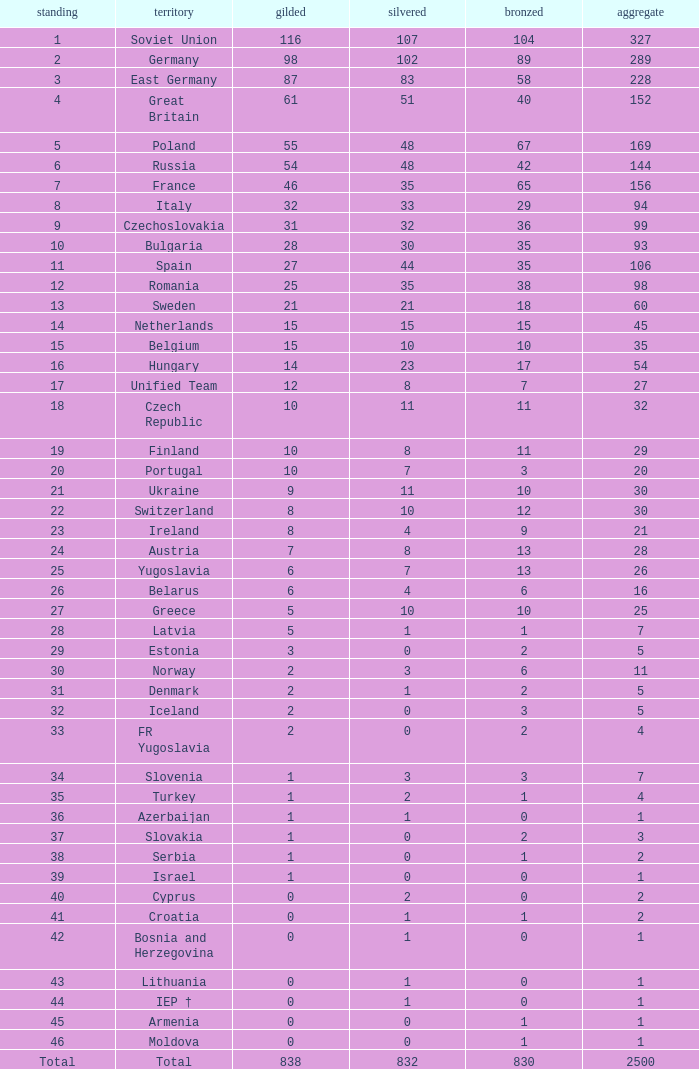What is the rank of the nation with more than 0 silver medals and 38 bronze medals? 12.0. 